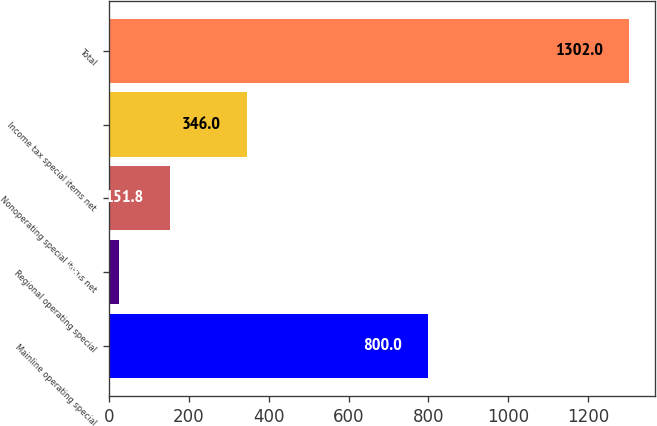Convert chart. <chart><loc_0><loc_0><loc_500><loc_500><bar_chart><fcel>Mainline operating special<fcel>Regional operating special<fcel>Nonoperating special items net<fcel>Income tax special items net<fcel>Total<nl><fcel>800<fcel>24<fcel>151.8<fcel>346<fcel>1302<nl></chart> 